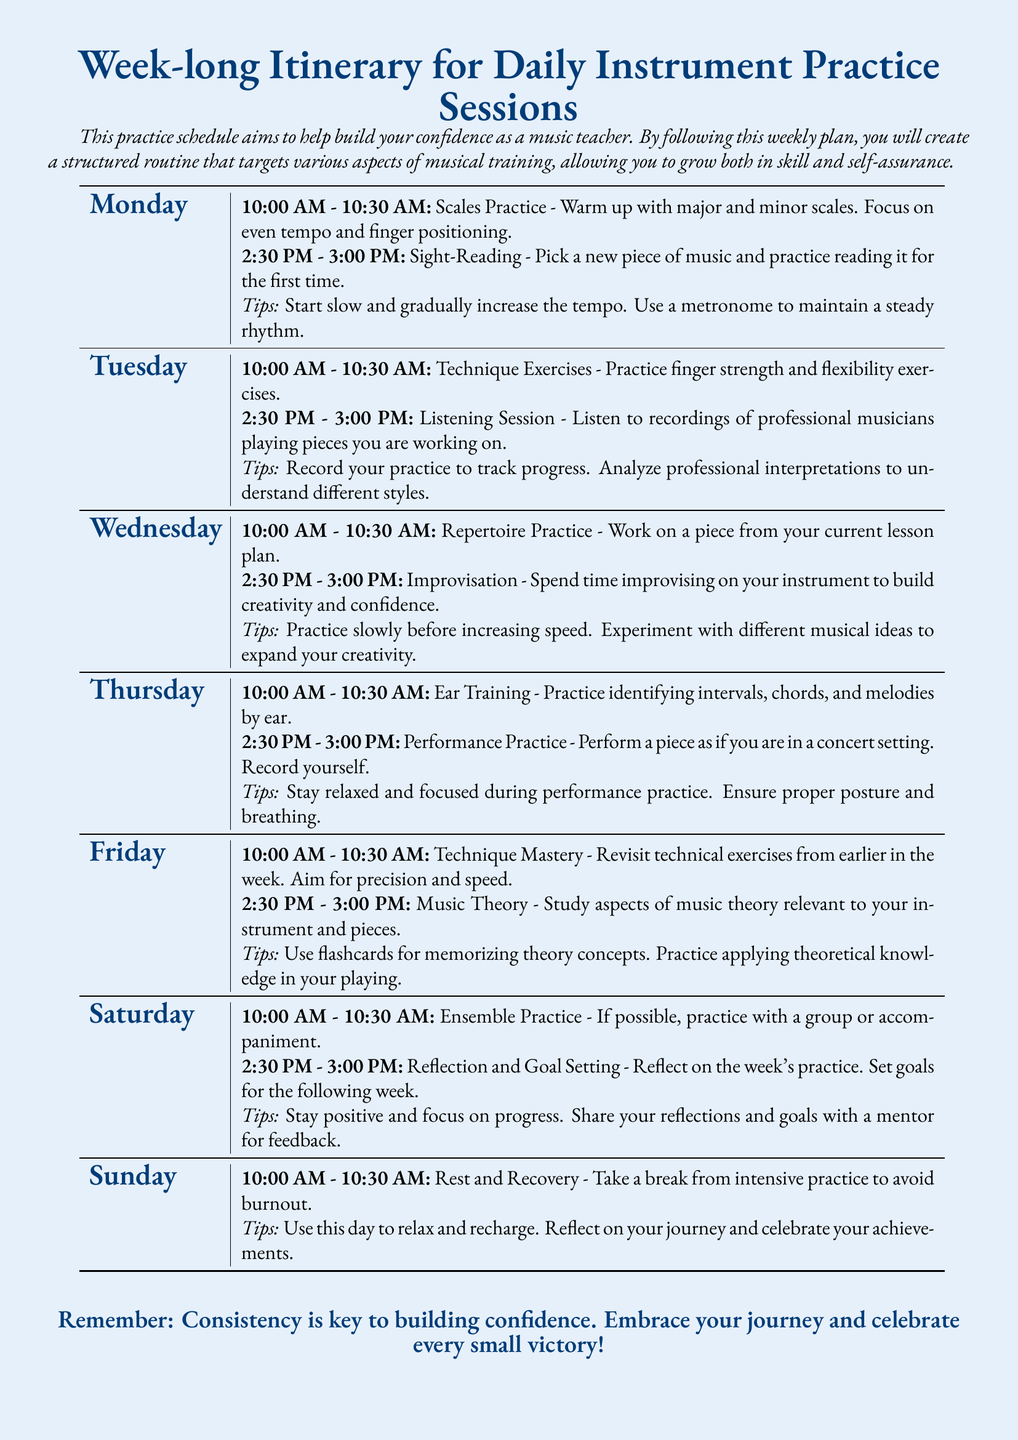What time is the scales practice on Monday? The schedule specifies that scales practice is from 10:00 AM to 10:30 AM on Monday.
Answer: 10:00 AM - 10:30 AM What type of exercises are practiced on Tuesday morning? The document states that Tuesday morning focuses on technique exercises.
Answer: Technique Exercises How long is the performance practice session on Thursday? The document indicates that the performance practice session lasts for 30 minutes.
Answer: 30 minutes What should you do during the Saturday session for reflection? The document advises to reflect on the week's practice during the Saturday session.
Answer: Reflect on the week's practice What is the main focus of the practice on Wednesday afternoon? The schedule outlines that Wednesday afternoon focuses on improvisation.
Answer: Improvisation Which day includes a rest and recovery session? The document specifies that Sunday is dedicated to rest and recovery.
Answer: Sunday What is one tip mentioned for sight-reading practice? The document suggests starting slow and gradually increasing the tempo as a tip for sight-reading.
Answer: Start slow and gradually increase the tempo What activity is recommended on Tuesday afternoon? The itinerary states that listening to recordings of professional musicians is recommended on Tuesday afternoon.
Answer: Listening Session Which day emphasizes ensemble practice? The schedule indicates that Saturday is the day for ensemble practice.
Answer: Saturday 